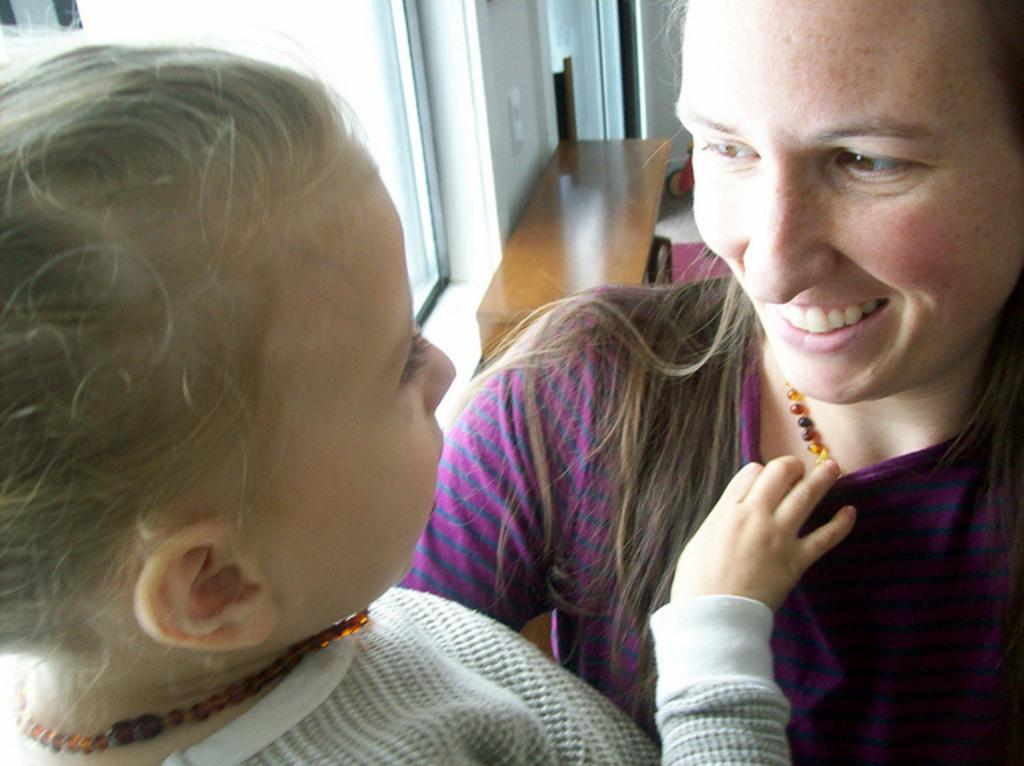How many people are in the image? There are two people in the image. What can be observed about the clothing of the people in the image? The people are wearing different color dresses. What is located in the background of the image? There is a wooden bench in the background of the image. What architectural feature is visible in the background of the image? There are windows visible in the background of the image, which are part of a wall. What type of unit is the carpenter working on in the image? There is no carpenter or unit present in the image. 